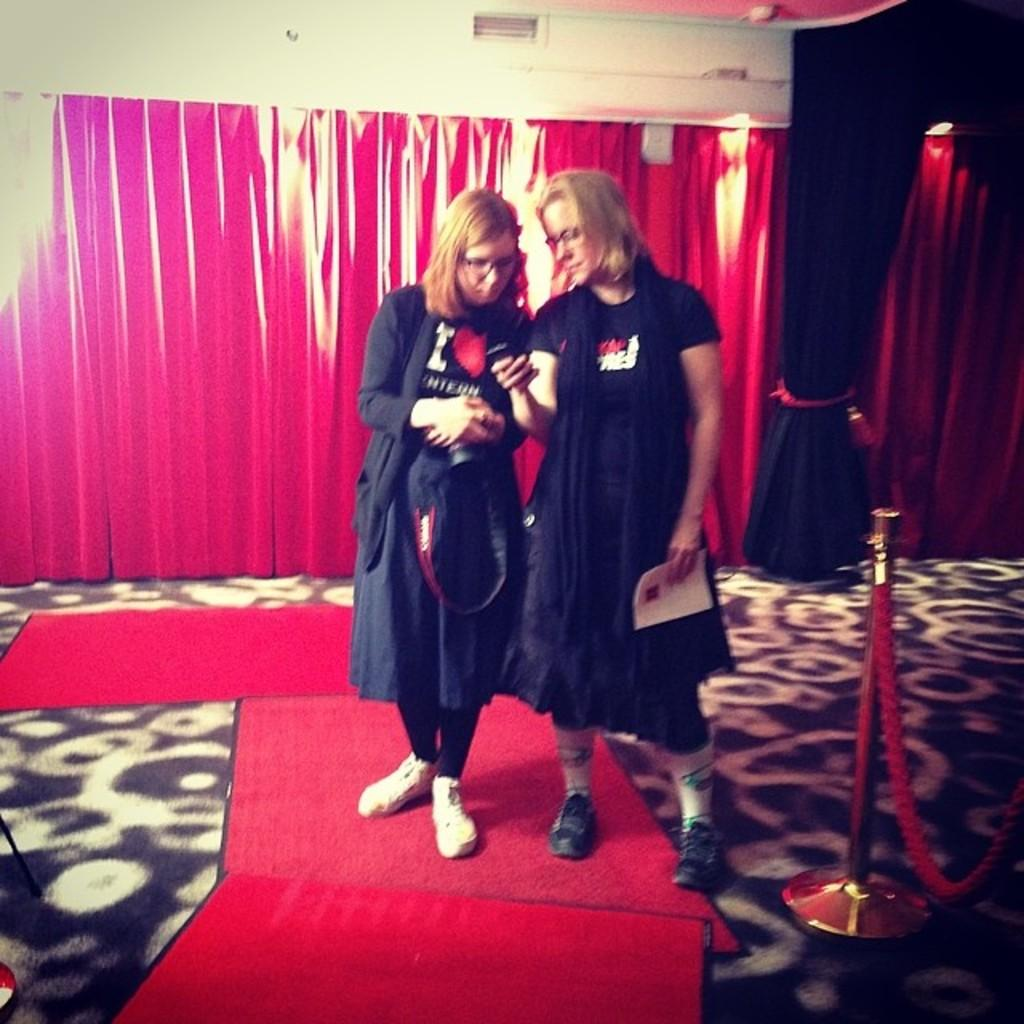How many women are present in the image? There are two women in the image. What is the surface on which the women are standing? The women are standing on a carpet. What can be seen behind the women in the image? There are curtains visible behind the women. What type of pump is being used by the women in the image? There is no pump present in the image, and the women are not using any pump. How are the women using the match in the image? There is no match present in the image, and the women are not using any match. 